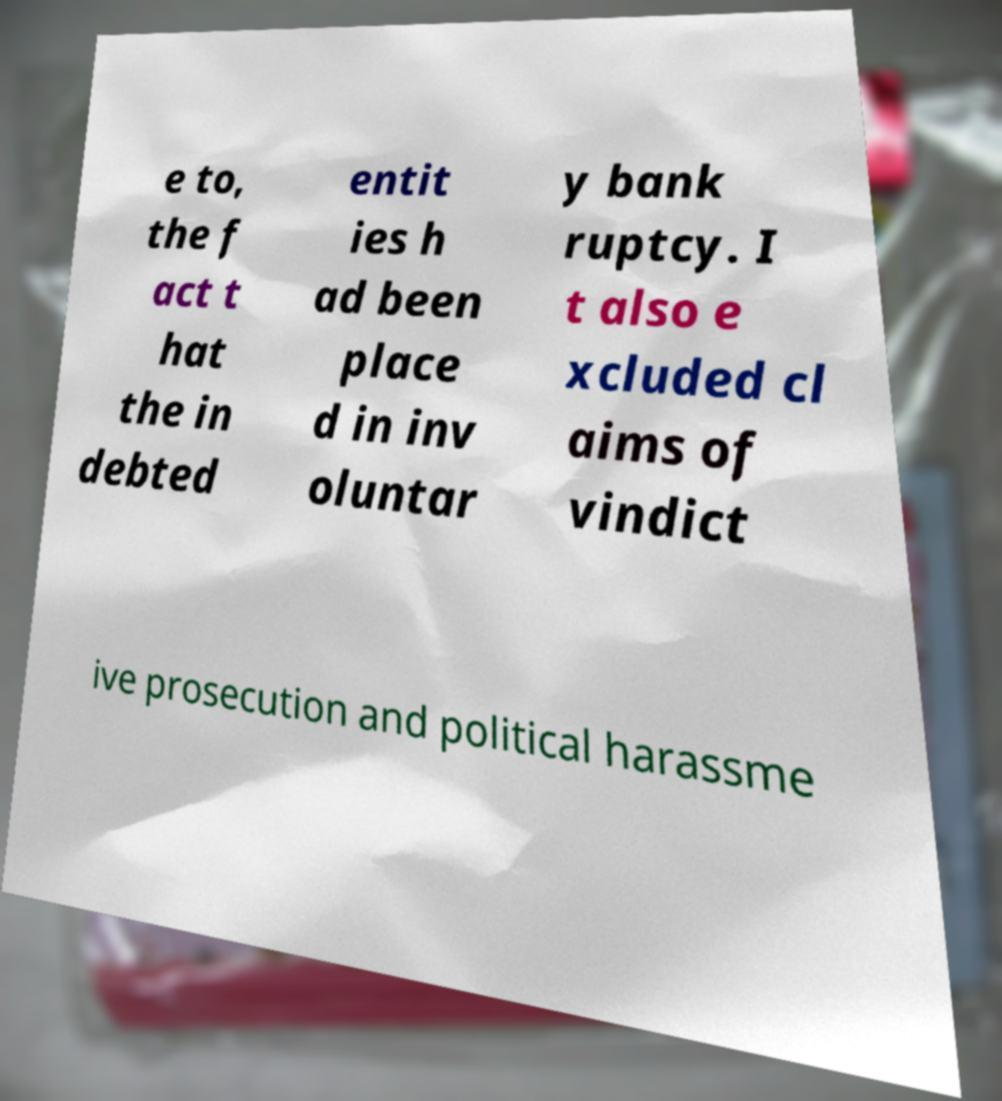I need the written content from this picture converted into text. Can you do that? e to, the f act t hat the in debted entit ies h ad been place d in inv oluntar y bank ruptcy. I t also e xcluded cl aims of vindict ive prosecution and political harassme 